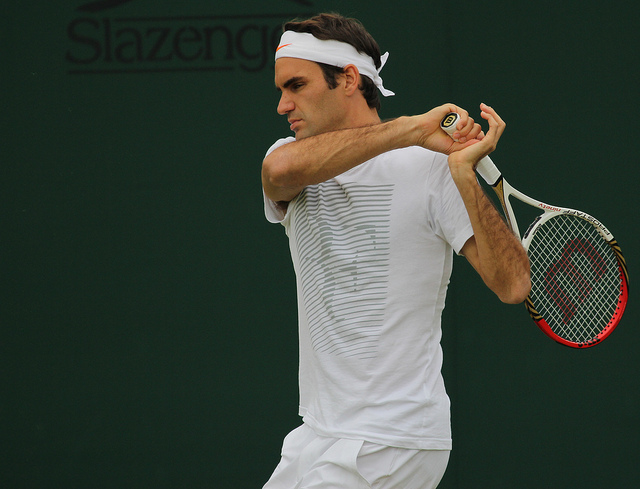Identify the text displayed in this image. Slazeng M 